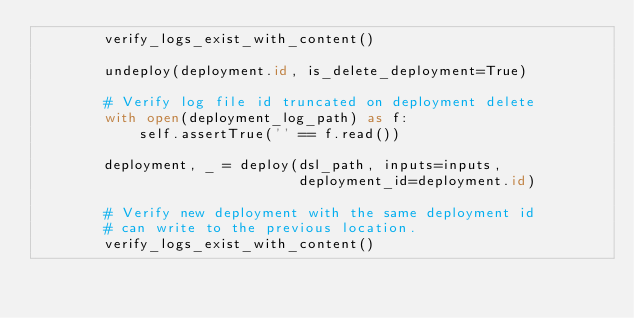<code> <loc_0><loc_0><loc_500><loc_500><_Python_>        verify_logs_exist_with_content()

        undeploy(deployment.id, is_delete_deployment=True)

        # Verify log file id truncated on deployment delete
        with open(deployment_log_path) as f:
            self.assertTrue('' == f.read())

        deployment, _ = deploy(dsl_path, inputs=inputs,
                               deployment_id=deployment.id)

        # Verify new deployment with the same deployment id
        # can write to the previous location.
        verify_logs_exist_with_content()
</code> 